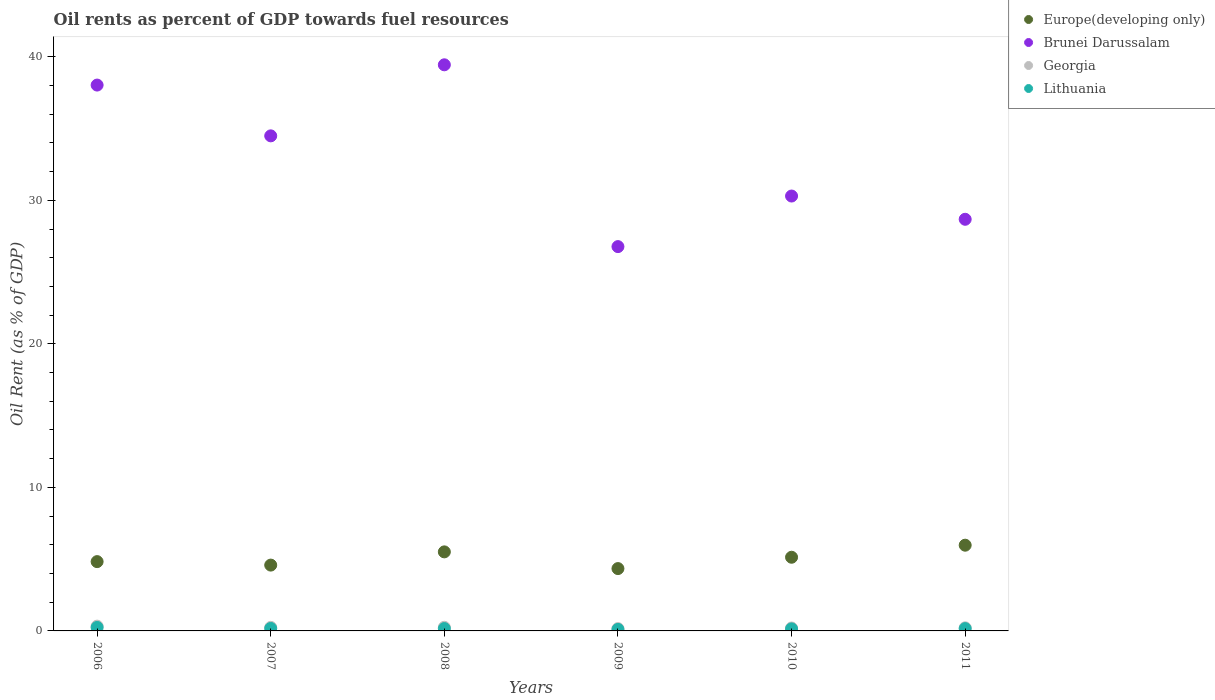How many different coloured dotlines are there?
Provide a succinct answer. 4. What is the oil rent in Lithuania in 2009?
Offer a very short reply. 0.11. Across all years, what is the maximum oil rent in Europe(developing only)?
Ensure brevity in your answer.  5.97. Across all years, what is the minimum oil rent in Brunei Darussalam?
Provide a succinct answer. 26.77. In which year was the oil rent in Brunei Darussalam minimum?
Ensure brevity in your answer.  2009. What is the total oil rent in Europe(developing only) in the graph?
Ensure brevity in your answer.  30.37. What is the difference between the oil rent in Europe(developing only) in 2008 and that in 2009?
Your response must be concise. 1.16. What is the difference between the oil rent in Lithuania in 2009 and the oil rent in Europe(developing only) in 2010?
Keep it short and to the point. -5.03. What is the average oil rent in Brunei Darussalam per year?
Make the answer very short. 32.95. In the year 2010, what is the difference between the oil rent in Georgia and oil rent in Brunei Darussalam?
Ensure brevity in your answer.  -30.09. In how many years, is the oil rent in Brunei Darussalam greater than 24 %?
Keep it short and to the point. 6. What is the ratio of the oil rent in Brunei Darussalam in 2007 to that in 2009?
Make the answer very short. 1.29. Is the oil rent in Georgia in 2009 less than that in 2011?
Ensure brevity in your answer.  Yes. Is the difference between the oil rent in Georgia in 2008 and 2011 greater than the difference between the oil rent in Brunei Darussalam in 2008 and 2011?
Keep it short and to the point. No. What is the difference between the highest and the second highest oil rent in Lithuania?
Provide a short and direct response. 0.07. What is the difference between the highest and the lowest oil rent in Brunei Darussalam?
Provide a short and direct response. 12.67. In how many years, is the oil rent in Georgia greater than the average oil rent in Georgia taken over all years?
Make the answer very short. 3. Is the sum of the oil rent in Brunei Darussalam in 2006 and 2011 greater than the maximum oil rent in Lithuania across all years?
Your answer should be very brief. Yes. Does the oil rent in Europe(developing only) monotonically increase over the years?
Your response must be concise. No. Is the oil rent in Georgia strictly greater than the oil rent in Europe(developing only) over the years?
Offer a terse response. No. Is the oil rent in Lithuania strictly less than the oil rent in Georgia over the years?
Offer a terse response. Yes. Where does the legend appear in the graph?
Make the answer very short. Top right. How are the legend labels stacked?
Offer a terse response. Vertical. What is the title of the graph?
Give a very brief answer. Oil rents as percent of GDP towards fuel resources. What is the label or title of the X-axis?
Provide a succinct answer. Years. What is the label or title of the Y-axis?
Provide a succinct answer. Oil Rent (as % of GDP). What is the Oil Rent (as % of GDP) of Europe(developing only) in 2006?
Provide a succinct answer. 4.83. What is the Oil Rent (as % of GDP) in Brunei Darussalam in 2006?
Your answer should be compact. 38.03. What is the Oil Rent (as % of GDP) of Georgia in 2006?
Give a very brief answer. 0.33. What is the Oil Rent (as % of GDP) in Lithuania in 2006?
Make the answer very short. 0.24. What is the Oil Rent (as % of GDP) of Europe(developing only) in 2007?
Provide a succinct answer. 4.59. What is the Oil Rent (as % of GDP) of Brunei Darussalam in 2007?
Give a very brief answer. 34.49. What is the Oil Rent (as % of GDP) in Georgia in 2007?
Give a very brief answer. 0.25. What is the Oil Rent (as % of GDP) in Lithuania in 2007?
Offer a very short reply. 0.17. What is the Oil Rent (as % of GDP) in Europe(developing only) in 2008?
Provide a short and direct response. 5.51. What is the Oil Rent (as % of GDP) of Brunei Darussalam in 2008?
Give a very brief answer. 39.44. What is the Oil Rent (as % of GDP) of Georgia in 2008?
Make the answer very short. 0.25. What is the Oil Rent (as % of GDP) of Lithuania in 2008?
Keep it short and to the point. 0.16. What is the Oil Rent (as % of GDP) of Europe(developing only) in 2009?
Give a very brief answer. 4.34. What is the Oil Rent (as % of GDP) in Brunei Darussalam in 2009?
Offer a terse response. 26.77. What is the Oil Rent (as % of GDP) of Georgia in 2009?
Offer a very short reply. 0.16. What is the Oil Rent (as % of GDP) of Lithuania in 2009?
Ensure brevity in your answer.  0.11. What is the Oil Rent (as % of GDP) of Europe(developing only) in 2010?
Your answer should be compact. 5.13. What is the Oil Rent (as % of GDP) of Brunei Darussalam in 2010?
Provide a succinct answer. 30.3. What is the Oil Rent (as % of GDP) of Georgia in 2010?
Keep it short and to the point. 0.2. What is the Oil Rent (as % of GDP) in Lithuania in 2010?
Your answer should be very brief. 0.14. What is the Oil Rent (as % of GDP) of Europe(developing only) in 2011?
Keep it short and to the point. 5.97. What is the Oil Rent (as % of GDP) of Brunei Darussalam in 2011?
Your response must be concise. 28.68. What is the Oil Rent (as % of GDP) of Georgia in 2011?
Provide a succinct answer. 0.22. What is the Oil Rent (as % of GDP) in Lithuania in 2011?
Provide a succinct answer. 0.16. Across all years, what is the maximum Oil Rent (as % of GDP) in Europe(developing only)?
Provide a short and direct response. 5.97. Across all years, what is the maximum Oil Rent (as % of GDP) in Brunei Darussalam?
Provide a short and direct response. 39.44. Across all years, what is the maximum Oil Rent (as % of GDP) in Georgia?
Ensure brevity in your answer.  0.33. Across all years, what is the maximum Oil Rent (as % of GDP) of Lithuania?
Your answer should be compact. 0.24. Across all years, what is the minimum Oil Rent (as % of GDP) of Europe(developing only)?
Provide a succinct answer. 4.34. Across all years, what is the minimum Oil Rent (as % of GDP) in Brunei Darussalam?
Your response must be concise. 26.77. Across all years, what is the minimum Oil Rent (as % of GDP) in Georgia?
Offer a terse response. 0.16. Across all years, what is the minimum Oil Rent (as % of GDP) in Lithuania?
Ensure brevity in your answer.  0.11. What is the total Oil Rent (as % of GDP) of Europe(developing only) in the graph?
Make the answer very short. 30.37. What is the total Oil Rent (as % of GDP) in Brunei Darussalam in the graph?
Ensure brevity in your answer.  197.71. What is the total Oil Rent (as % of GDP) of Georgia in the graph?
Offer a terse response. 1.42. What is the total Oil Rent (as % of GDP) of Lithuania in the graph?
Your answer should be very brief. 0.99. What is the difference between the Oil Rent (as % of GDP) of Europe(developing only) in 2006 and that in 2007?
Make the answer very short. 0.24. What is the difference between the Oil Rent (as % of GDP) in Brunei Darussalam in 2006 and that in 2007?
Offer a terse response. 3.54. What is the difference between the Oil Rent (as % of GDP) of Georgia in 2006 and that in 2007?
Your answer should be very brief. 0.08. What is the difference between the Oil Rent (as % of GDP) of Lithuania in 2006 and that in 2007?
Make the answer very short. 0.07. What is the difference between the Oil Rent (as % of GDP) of Europe(developing only) in 2006 and that in 2008?
Give a very brief answer. -0.68. What is the difference between the Oil Rent (as % of GDP) of Brunei Darussalam in 2006 and that in 2008?
Keep it short and to the point. -1.41. What is the difference between the Oil Rent (as % of GDP) of Georgia in 2006 and that in 2008?
Your answer should be very brief. 0.08. What is the difference between the Oil Rent (as % of GDP) of Lithuania in 2006 and that in 2008?
Your answer should be very brief. 0.08. What is the difference between the Oil Rent (as % of GDP) of Europe(developing only) in 2006 and that in 2009?
Give a very brief answer. 0.48. What is the difference between the Oil Rent (as % of GDP) of Brunei Darussalam in 2006 and that in 2009?
Your response must be concise. 11.25. What is the difference between the Oil Rent (as % of GDP) of Georgia in 2006 and that in 2009?
Your answer should be very brief. 0.17. What is the difference between the Oil Rent (as % of GDP) in Lithuania in 2006 and that in 2009?
Keep it short and to the point. 0.14. What is the difference between the Oil Rent (as % of GDP) in Europe(developing only) in 2006 and that in 2010?
Keep it short and to the point. -0.3. What is the difference between the Oil Rent (as % of GDP) in Brunei Darussalam in 2006 and that in 2010?
Offer a very short reply. 7.73. What is the difference between the Oil Rent (as % of GDP) in Georgia in 2006 and that in 2010?
Ensure brevity in your answer.  0.13. What is the difference between the Oil Rent (as % of GDP) in Lithuania in 2006 and that in 2010?
Your answer should be very brief. 0.1. What is the difference between the Oil Rent (as % of GDP) of Europe(developing only) in 2006 and that in 2011?
Offer a terse response. -1.14. What is the difference between the Oil Rent (as % of GDP) in Brunei Darussalam in 2006 and that in 2011?
Your answer should be compact. 9.35. What is the difference between the Oil Rent (as % of GDP) of Georgia in 2006 and that in 2011?
Your answer should be very brief. 0.12. What is the difference between the Oil Rent (as % of GDP) of Lithuania in 2006 and that in 2011?
Offer a terse response. 0.08. What is the difference between the Oil Rent (as % of GDP) in Europe(developing only) in 2007 and that in 2008?
Offer a very short reply. -0.92. What is the difference between the Oil Rent (as % of GDP) in Brunei Darussalam in 2007 and that in 2008?
Give a very brief answer. -4.95. What is the difference between the Oil Rent (as % of GDP) in Georgia in 2007 and that in 2008?
Keep it short and to the point. -0. What is the difference between the Oil Rent (as % of GDP) in Lithuania in 2007 and that in 2008?
Offer a very short reply. 0.01. What is the difference between the Oil Rent (as % of GDP) of Europe(developing only) in 2007 and that in 2009?
Provide a short and direct response. 0.24. What is the difference between the Oil Rent (as % of GDP) in Brunei Darussalam in 2007 and that in 2009?
Make the answer very short. 7.72. What is the difference between the Oil Rent (as % of GDP) in Georgia in 2007 and that in 2009?
Provide a short and direct response. 0.09. What is the difference between the Oil Rent (as % of GDP) of Lithuania in 2007 and that in 2009?
Make the answer very short. 0.07. What is the difference between the Oil Rent (as % of GDP) in Europe(developing only) in 2007 and that in 2010?
Offer a terse response. -0.55. What is the difference between the Oil Rent (as % of GDP) in Brunei Darussalam in 2007 and that in 2010?
Your answer should be compact. 4.19. What is the difference between the Oil Rent (as % of GDP) in Georgia in 2007 and that in 2010?
Provide a succinct answer. 0.04. What is the difference between the Oil Rent (as % of GDP) of Lithuania in 2007 and that in 2010?
Offer a terse response. 0.03. What is the difference between the Oil Rent (as % of GDP) in Europe(developing only) in 2007 and that in 2011?
Provide a short and direct response. -1.39. What is the difference between the Oil Rent (as % of GDP) in Brunei Darussalam in 2007 and that in 2011?
Provide a short and direct response. 5.81. What is the difference between the Oil Rent (as % of GDP) of Georgia in 2007 and that in 2011?
Provide a short and direct response. 0.03. What is the difference between the Oil Rent (as % of GDP) in Lithuania in 2007 and that in 2011?
Your response must be concise. 0.01. What is the difference between the Oil Rent (as % of GDP) of Europe(developing only) in 2008 and that in 2009?
Offer a terse response. 1.16. What is the difference between the Oil Rent (as % of GDP) of Brunei Darussalam in 2008 and that in 2009?
Ensure brevity in your answer.  12.67. What is the difference between the Oil Rent (as % of GDP) in Georgia in 2008 and that in 2009?
Provide a short and direct response. 0.09. What is the difference between the Oil Rent (as % of GDP) of Lithuania in 2008 and that in 2009?
Provide a short and direct response. 0.06. What is the difference between the Oil Rent (as % of GDP) in Europe(developing only) in 2008 and that in 2010?
Make the answer very short. 0.37. What is the difference between the Oil Rent (as % of GDP) in Brunei Darussalam in 2008 and that in 2010?
Provide a succinct answer. 9.14. What is the difference between the Oil Rent (as % of GDP) in Georgia in 2008 and that in 2010?
Your answer should be very brief. 0.05. What is the difference between the Oil Rent (as % of GDP) of Lithuania in 2008 and that in 2010?
Your answer should be compact. 0.02. What is the difference between the Oil Rent (as % of GDP) of Europe(developing only) in 2008 and that in 2011?
Provide a succinct answer. -0.47. What is the difference between the Oil Rent (as % of GDP) of Brunei Darussalam in 2008 and that in 2011?
Offer a very short reply. 10.76. What is the difference between the Oil Rent (as % of GDP) in Georgia in 2008 and that in 2011?
Keep it short and to the point. 0.04. What is the difference between the Oil Rent (as % of GDP) in Lithuania in 2008 and that in 2011?
Make the answer very short. 0. What is the difference between the Oil Rent (as % of GDP) in Europe(developing only) in 2009 and that in 2010?
Give a very brief answer. -0.79. What is the difference between the Oil Rent (as % of GDP) of Brunei Darussalam in 2009 and that in 2010?
Your response must be concise. -3.52. What is the difference between the Oil Rent (as % of GDP) of Georgia in 2009 and that in 2010?
Ensure brevity in your answer.  -0.04. What is the difference between the Oil Rent (as % of GDP) in Lithuania in 2009 and that in 2010?
Your response must be concise. -0.04. What is the difference between the Oil Rent (as % of GDP) in Europe(developing only) in 2009 and that in 2011?
Give a very brief answer. -1.63. What is the difference between the Oil Rent (as % of GDP) of Brunei Darussalam in 2009 and that in 2011?
Offer a very short reply. -1.9. What is the difference between the Oil Rent (as % of GDP) of Georgia in 2009 and that in 2011?
Provide a short and direct response. -0.05. What is the difference between the Oil Rent (as % of GDP) in Lithuania in 2009 and that in 2011?
Ensure brevity in your answer.  -0.06. What is the difference between the Oil Rent (as % of GDP) of Europe(developing only) in 2010 and that in 2011?
Your response must be concise. -0.84. What is the difference between the Oil Rent (as % of GDP) of Brunei Darussalam in 2010 and that in 2011?
Give a very brief answer. 1.62. What is the difference between the Oil Rent (as % of GDP) of Georgia in 2010 and that in 2011?
Make the answer very short. -0.01. What is the difference between the Oil Rent (as % of GDP) of Lithuania in 2010 and that in 2011?
Your answer should be compact. -0.02. What is the difference between the Oil Rent (as % of GDP) in Europe(developing only) in 2006 and the Oil Rent (as % of GDP) in Brunei Darussalam in 2007?
Make the answer very short. -29.66. What is the difference between the Oil Rent (as % of GDP) of Europe(developing only) in 2006 and the Oil Rent (as % of GDP) of Georgia in 2007?
Your response must be concise. 4.58. What is the difference between the Oil Rent (as % of GDP) in Europe(developing only) in 2006 and the Oil Rent (as % of GDP) in Lithuania in 2007?
Offer a terse response. 4.66. What is the difference between the Oil Rent (as % of GDP) of Brunei Darussalam in 2006 and the Oil Rent (as % of GDP) of Georgia in 2007?
Your answer should be very brief. 37.78. What is the difference between the Oil Rent (as % of GDP) in Brunei Darussalam in 2006 and the Oil Rent (as % of GDP) in Lithuania in 2007?
Ensure brevity in your answer.  37.86. What is the difference between the Oil Rent (as % of GDP) of Georgia in 2006 and the Oil Rent (as % of GDP) of Lithuania in 2007?
Your answer should be compact. 0.16. What is the difference between the Oil Rent (as % of GDP) of Europe(developing only) in 2006 and the Oil Rent (as % of GDP) of Brunei Darussalam in 2008?
Offer a terse response. -34.61. What is the difference between the Oil Rent (as % of GDP) in Europe(developing only) in 2006 and the Oil Rent (as % of GDP) in Georgia in 2008?
Ensure brevity in your answer.  4.57. What is the difference between the Oil Rent (as % of GDP) of Europe(developing only) in 2006 and the Oil Rent (as % of GDP) of Lithuania in 2008?
Your answer should be very brief. 4.66. What is the difference between the Oil Rent (as % of GDP) in Brunei Darussalam in 2006 and the Oil Rent (as % of GDP) in Georgia in 2008?
Give a very brief answer. 37.77. What is the difference between the Oil Rent (as % of GDP) in Brunei Darussalam in 2006 and the Oil Rent (as % of GDP) in Lithuania in 2008?
Provide a succinct answer. 37.86. What is the difference between the Oil Rent (as % of GDP) of Georgia in 2006 and the Oil Rent (as % of GDP) of Lithuania in 2008?
Your answer should be compact. 0.17. What is the difference between the Oil Rent (as % of GDP) in Europe(developing only) in 2006 and the Oil Rent (as % of GDP) in Brunei Darussalam in 2009?
Offer a very short reply. -21.95. What is the difference between the Oil Rent (as % of GDP) of Europe(developing only) in 2006 and the Oil Rent (as % of GDP) of Georgia in 2009?
Ensure brevity in your answer.  4.66. What is the difference between the Oil Rent (as % of GDP) in Europe(developing only) in 2006 and the Oil Rent (as % of GDP) in Lithuania in 2009?
Give a very brief answer. 4.72. What is the difference between the Oil Rent (as % of GDP) in Brunei Darussalam in 2006 and the Oil Rent (as % of GDP) in Georgia in 2009?
Your answer should be very brief. 37.87. What is the difference between the Oil Rent (as % of GDP) of Brunei Darussalam in 2006 and the Oil Rent (as % of GDP) of Lithuania in 2009?
Ensure brevity in your answer.  37.92. What is the difference between the Oil Rent (as % of GDP) in Georgia in 2006 and the Oil Rent (as % of GDP) in Lithuania in 2009?
Your answer should be very brief. 0.23. What is the difference between the Oil Rent (as % of GDP) in Europe(developing only) in 2006 and the Oil Rent (as % of GDP) in Brunei Darussalam in 2010?
Your answer should be very brief. -25.47. What is the difference between the Oil Rent (as % of GDP) in Europe(developing only) in 2006 and the Oil Rent (as % of GDP) in Georgia in 2010?
Offer a very short reply. 4.62. What is the difference between the Oil Rent (as % of GDP) in Europe(developing only) in 2006 and the Oil Rent (as % of GDP) in Lithuania in 2010?
Provide a short and direct response. 4.69. What is the difference between the Oil Rent (as % of GDP) in Brunei Darussalam in 2006 and the Oil Rent (as % of GDP) in Georgia in 2010?
Ensure brevity in your answer.  37.82. What is the difference between the Oil Rent (as % of GDP) in Brunei Darussalam in 2006 and the Oil Rent (as % of GDP) in Lithuania in 2010?
Give a very brief answer. 37.89. What is the difference between the Oil Rent (as % of GDP) in Georgia in 2006 and the Oil Rent (as % of GDP) in Lithuania in 2010?
Provide a succinct answer. 0.19. What is the difference between the Oil Rent (as % of GDP) of Europe(developing only) in 2006 and the Oil Rent (as % of GDP) of Brunei Darussalam in 2011?
Provide a short and direct response. -23.85. What is the difference between the Oil Rent (as % of GDP) of Europe(developing only) in 2006 and the Oil Rent (as % of GDP) of Georgia in 2011?
Make the answer very short. 4.61. What is the difference between the Oil Rent (as % of GDP) of Europe(developing only) in 2006 and the Oil Rent (as % of GDP) of Lithuania in 2011?
Offer a terse response. 4.67. What is the difference between the Oil Rent (as % of GDP) of Brunei Darussalam in 2006 and the Oil Rent (as % of GDP) of Georgia in 2011?
Keep it short and to the point. 37.81. What is the difference between the Oil Rent (as % of GDP) in Brunei Darussalam in 2006 and the Oil Rent (as % of GDP) in Lithuania in 2011?
Offer a terse response. 37.87. What is the difference between the Oil Rent (as % of GDP) in Georgia in 2006 and the Oil Rent (as % of GDP) in Lithuania in 2011?
Your response must be concise. 0.17. What is the difference between the Oil Rent (as % of GDP) in Europe(developing only) in 2007 and the Oil Rent (as % of GDP) in Brunei Darussalam in 2008?
Make the answer very short. -34.85. What is the difference between the Oil Rent (as % of GDP) of Europe(developing only) in 2007 and the Oil Rent (as % of GDP) of Georgia in 2008?
Offer a very short reply. 4.33. What is the difference between the Oil Rent (as % of GDP) in Europe(developing only) in 2007 and the Oil Rent (as % of GDP) in Lithuania in 2008?
Your response must be concise. 4.42. What is the difference between the Oil Rent (as % of GDP) of Brunei Darussalam in 2007 and the Oil Rent (as % of GDP) of Georgia in 2008?
Ensure brevity in your answer.  34.24. What is the difference between the Oil Rent (as % of GDP) in Brunei Darussalam in 2007 and the Oil Rent (as % of GDP) in Lithuania in 2008?
Keep it short and to the point. 34.33. What is the difference between the Oil Rent (as % of GDP) of Georgia in 2007 and the Oil Rent (as % of GDP) of Lithuania in 2008?
Your response must be concise. 0.09. What is the difference between the Oil Rent (as % of GDP) in Europe(developing only) in 2007 and the Oil Rent (as % of GDP) in Brunei Darussalam in 2009?
Ensure brevity in your answer.  -22.19. What is the difference between the Oil Rent (as % of GDP) of Europe(developing only) in 2007 and the Oil Rent (as % of GDP) of Georgia in 2009?
Ensure brevity in your answer.  4.42. What is the difference between the Oil Rent (as % of GDP) of Europe(developing only) in 2007 and the Oil Rent (as % of GDP) of Lithuania in 2009?
Offer a terse response. 4.48. What is the difference between the Oil Rent (as % of GDP) in Brunei Darussalam in 2007 and the Oil Rent (as % of GDP) in Georgia in 2009?
Your answer should be compact. 34.33. What is the difference between the Oil Rent (as % of GDP) of Brunei Darussalam in 2007 and the Oil Rent (as % of GDP) of Lithuania in 2009?
Keep it short and to the point. 34.38. What is the difference between the Oil Rent (as % of GDP) of Georgia in 2007 and the Oil Rent (as % of GDP) of Lithuania in 2009?
Your response must be concise. 0.14. What is the difference between the Oil Rent (as % of GDP) in Europe(developing only) in 2007 and the Oil Rent (as % of GDP) in Brunei Darussalam in 2010?
Ensure brevity in your answer.  -25.71. What is the difference between the Oil Rent (as % of GDP) in Europe(developing only) in 2007 and the Oil Rent (as % of GDP) in Georgia in 2010?
Offer a very short reply. 4.38. What is the difference between the Oil Rent (as % of GDP) of Europe(developing only) in 2007 and the Oil Rent (as % of GDP) of Lithuania in 2010?
Your answer should be very brief. 4.44. What is the difference between the Oil Rent (as % of GDP) in Brunei Darussalam in 2007 and the Oil Rent (as % of GDP) in Georgia in 2010?
Offer a very short reply. 34.29. What is the difference between the Oil Rent (as % of GDP) of Brunei Darussalam in 2007 and the Oil Rent (as % of GDP) of Lithuania in 2010?
Keep it short and to the point. 34.35. What is the difference between the Oil Rent (as % of GDP) in Georgia in 2007 and the Oil Rent (as % of GDP) in Lithuania in 2010?
Offer a terse response. 0.11. What is the difference between the Oil Rent (as % of GDP) in Europe(developing only) in 2007 and the Oil Rent (as % of GDP) in Brunei Darussalam in 2011?
Offer a very short reply. -24.09. What is the difference between the Oil Rent (as % of GDP) in Europe(developing only) in 2007 and the Oil Rent (as % of GDP) in Georgia in 2011?
Offer a very short reply. 4.37. What is the difference between the Oil Rent (as % of GDP) in Europe(developing only) in 2007 and the Oil Rent (as % of GDP) in Lithuania in 2011?
Provide a short and direct response. 4.42. What is the difference between the Oil Rent (as % of GDP) of Brunei Darussalam in 2007 and the Oil Rent (as % of GDP) of Georgia in 2011?
Your answer should be compact. 34.27. What is the difference between the Oil Rent (as % of GDP) of Brunei Darussalam in 2007 and the Oil Rent (as % of GDP) of Lithuania in 2011?
Make the answer very short. 34.33. What is the difference between the Oil Rent (as % of GDP) in Georgia in 2007 and the Oil Rent (as % of GDP) in Lithuania in 2011?
Provide a short and direct response. 0.09. What is the difference between the Oil Rent (as % of GDP) of Europe(developing only) in 2008 and the Oil Rent (as % of GDP) of Brunei Darussalam in 2009?
Provide a succinct answer. -21.27. What is the difference between the Oil Rent (as % of GDP) of Europe(developing only) in 2008 and the Oil Rent (as % of GDP) of Georgia in 2009?
Provide a short and direct response. 5.34. What is the difference between the Oil Rent (as % of GDP) of Europe(developing only) in 2008 and the Oil Rent (as % of GDP) of Lithuania in 2009?
Keep it short and to the point. 5.4. What is the difference between the Oil Rent (as % of GDP) of Brunei Darussalam in 2008 and the Oil Rent (as % of GDP) of Georgia in 2009?
Your answer should be very brief. 39.28. What is the difference between the Oil Rent (as % of GDP) of Brunei Darussalam in 2008 and the Oil Rent (as % of GDP) of Lithuania in 2009?
Keep it short and to the point. 39.33. What is the difference between the Oil Rent (as % of GDP) in Georgia in 2008 and the Oil Rent (as % of GDP) in Lithuania in 2009?
Your answer should be very brief. 0.15. What is the difference between the Oil Rent (as % of GDP) of Europe(developing only) in 2008 and the Oil Rent (as % of GDP) of Brunei Darussalam in 2010?
Ensure brevity in your answer.  -24.79. What is the difference between the Oil Rent (as % of GDP) in Europe(developing only) in 2008 and the Oil Rent (as % of GDP) in Georgia in 2010?
Provide a succinct answer. 5.3. What is the difference between the Oil Rent (as % of GDP) in Europe(developing only) in 2008 and the Oil Rent (as % of GDP) in Lithuania in 2010?
Provide a short and direct response. 5.37. What is the difference between the Oil Rent (as % of GDP) of Brunei Darussalam in 2008 and the Oil Rent (as % of GDP) of Georgia in 2010?
Your answer should be compact. 39.24. What is the difference between the Oil Rent (as % of GDP) of Brunei Darussalam in 2008 and the Oil Rent (as % of GDP) of Lithuania in 2010?
Provide a succinct answer. 39.3. What is the difference between the Oil Rent (as % of GDP) of Georgia in 2008 and the Oil Rent (as % of GDP) of Lithuania in 2010?
Keep it short and to the point. 0.11. What is the difference between the Oil Rent (as % of GDP) in Europe(developing only) in 2008 and the Oil Rent (as % of GDP) in Brunei Darussalam in 2011?
Provide a short and direct response. -23.17. What is the difference between the Oil Rent (as % of GDP) in Europe(developing only) in 2008 and the Oil Rent (as % of GDP) in Georgia in 2011?
Your response must be concise. 5.29. What is the difference between the Oil Rent (as % of GDP) of Europe(developing only) in 2008 and the Oil Rent (as % of GDP) of Lithuania in 2011?
Offer a very short reply. 5.35. What is the difference between the Oil Rent (as % of GDP) of Brunei Darussalam in 2008 and the Oil Rent (as % of GDP) of Georgia in 2011?
Your answer should be compact. 39.22. What is the difference between the Oil Rent (as % of GDP) of Brunei Darussalam in 2008 and the Oil Rent (as % of GDP) of Lithuania in 2011?
Provide a succinct answer. 39.28. What is the difference between the Oil Rent (as % of GDP) in Georgia in 2008 and the Oil Rent (as % of GDP) in Lithuania in 2011?
Give a very brief answer. 0.09. What is the difference between the Oil Rent (as % of GDP) in Europe(developing only) in 2009 and the Oil Rent (as % of GDP) in Brunei Darussalam in 2010?
Ensure brevity in your answer.  -25.95. What is the difference between the Oil Rent (as % of GDP) in Europe(developing only) in 2009 and the Oil Rent (as % of GDP) in Georgia in 2010?
Provide a short and direct response. 4.14. What is the difference between the Oil Rent (as % of GDP) of Europe(developing only) in 2009 and the Oil Rent (as % of GDP) of Lithuania in 2010?
Make the answer very short. 4.2. What is the difference between the Oil Rent (as % of GDP) of Brunei Darussalam in 2009 and the Oil Rent (as % of GDP) of Georgia in 2010?
Your answer should be compact. 26.57. What is the difference between the Oil Rent (as % of GDP) in Brunei Darussalam in 2009 and the Oil Rent (as % of GDP) in Lithuania in 2010?
Your answer should be very brief. 26.63. What is the difference between the Oil Rent (as % of GDP) in Georgia in 2009 and the Oil Rent (as % of GDP) in Lithuania in 2010?
Your response must be concise. 0.02. What is the difference between the Oil Rent (as % of GDP) in Europe(developing only) in 2009 and the Oil Rent (as % of GDP) in Brunei Darussalam in 2011?
Your answer should be very brief. -24.33. What is the difference between the Oil Rent (as % of GDP) in Europe(developing only) in 2009 and the Oil Rent (as % of GDP) in Georgia in 2011?
Your answer should be compact. 4.13. What is the difference between the Oil Rent (as % of GDP) of Europe(developing only) in 2009 and the Oil Rent (as % of GDP) of Lithuania in 2011?
Keep it short and to the point. 4.18. What is the difference between the Oil Rent (as % of GDP) in Brunei Darussalam in 2009 and the Oil Rent (as % of GDP) in Georgia in 2011?
Give a very brief answer. 26.56. What is the difference between the Oil Rent (as % of GDP) in Brunei Darussalam in 2009 and the Oil Rent (as % of GDP) in Lithuania in 2011?
Offer a terse response. 26.61. What is the difference between the Oil Rent (as % of GDP) of Georgia in 2009 and the Oil Rent (as % of GDP) of Lithuania in 2011?
Offer a very short reply. 0. What is the difference between the Oil Rent (as % of GDP) of Europe(developing only) in 2010 and the Oil Rent (as % of GDP) of Brunei Darussalam in 2011?
Offer a very short reply. -23.55. What is the difference between the Oil Rent (as % of GDP) of Europe(developing only) in 2010 and the Oil Rent (as % of GDP) of Georgia in 2011?
Your answer should be very brief. 4.92. What is the difference between the Oil Rent (as % of GDP) in Europe(developing only) in 2010 and the Oil Rent (as % of GDP) in Lithuania in 2011?
Your answer should be compact. 4.97. What is the difference between the Oil Rent (as % of GDP) of Brunei Darussalam in 2010 and the Oil Rent (as % of GDP) of Georgia in 2011?
Provide a short and direct response. 30.08. What is the difference between the Oil Rent (as % of GDP) of Brunei Darussalam in 2010 and the Oil Rent (as % of GDP) of Lithuania in 2011?
Your answer should be very brief. 30.14. What is the difference between the Oil Rent (as % of GDP) in Georgia in 2010 and the Oil Rent (as % of GDP) in Lithuania in 2011?
Your answer should be very brief. 0.04. What is the average Oil Rent (as % of GDP) in Europe(developing only) per year?
Keep it short and to the point. 5.06. What is the average Oil Rent (as % of GDP) of Brunei Darussalam per year?
Keep it short and to the point. 32.95. What is the average Oil Rent (as % of GDP) of Georgia per year?
Provide a succinct answer. 0.24. What is the average Oil Rent (as % of GDP) in Lithuania per year?
Give a very brief answer. 0.16. In the year 2006, what is the difference between the Oil Rent (as % of GDP) in Europe(developing only) and Oil Rent (as % of GDP) in Brunei Darussalam?
Your answer should be compact. -33.2. In the year 2006, what is the difference between the Oil Rent (as % of GDP) in Europe(developing only) and Oil Rent (as % of GDP) in Georgia?
Ensure brevity in your answer.  4.49. In the year 2006, what is the difference between the Oil Rent (as % of GDP) of Europe(developing only) and Oil Rent (as % of GDP) of Lithuania?
Keep it short and to the point. 4.59. In the year 2006, what is the difference between the Oil Rent (as % of GDP) of Brunei Darussalam and Oil Rent (as % of GDP) of Georgia?
Provide a short and direct response. 37.69. In the year 2006, what is the difference between the Oil Rent (as % of GDP) in Brunei Darussalam and Oil Rent (as % of GDP) in Lithuania?
Provide a short and direct response. 37.79. In the year 2006, what is the difference between the Oil Rent (as % of GDP) in Georgia and Oil Rent (as % of GDP) in Lithuania?
Provide a succinct answer. 0.09. In the year 2007, what is the difference between the Oil Rent (as % of GDP) in Europe(developing only) and Oil Rent (as % of GDP) in Brunei Darussalam?
Your response must be concise. -29.9. In the year 2007, what is the difference between the Oil Rent (as % of GDP) of Europe(developing only) and Oil Rent (as % of GDP) of Georgia?
Offer a very short reply. 4.34. In the year 2007, what is the difference between the Oil Rent (as % of GDP) in Europe(developing only) and Oil Rent (as % of GDP) in Lithuania?
Your answer should be compact. 4.41. In the year 2007, what is the difference between the Oil Rent (as % of GDP) of Brunei Darussalam and Oil Rent (as % of GDP) of Georgia?
Your answer should be very brief. 34.24. In the year 2007, what is the difference between the Oil Rent (as % of GDP) of Brunei Darussalam and Oil Rent (as % of GDP) of Lithuania?
Offer a terse response. 34.32. In the year 2007, what is the difference between the Oil Rent (as % of GDP) of Georgia and Oil Rent (as % of GDP) of Lithuania?
Keep it short and to the point. 0.08. In the year 2008, what is the difference between the Oil Rent (as % of GDP) of Europe(developing only) and Oil Rent (as % of GDP) of Brunei Darussalam?
Your answer should be compact. -33.93. In the year 2008, what is the difference between the Oil Rent (as % of GDP) of Europe(developing only) and Oil Rent (as % of GDP) of Georgia?
Your response must be concise. 5.25. In the year 2008, what is the difference between the Oil Rent (as % of GDP) of Europe(developing only) and Oil Rent (as % of GDP) of Lithuania?
Your response must be concise. 5.34. In the year 2008, what is the difference between the Oil Rent (as % of GDP) of Brunei Darussalam and Oil Rent (as % of GDP) of Georgia?
Provide a succinct answer. 39.19. In the year 2008, what is the difference between the Oil Rent (as % of GDP) of Brunei Darussalam and Oil Rent (as % of GDP) of Lithuania?
Provide a succinct answer. 39.28. In the year 2008, what is the difference between the Oil Rent (as % of GDP) in Georgia and Oil Rent (as % of GDP) in Lithuania?
Provide a succinct answer. 0.09. In the year 2009, what is the difference between the Oil Rent (as % of GDP) in Europe(developing only) and Oil Rent (as % of GDP) in Brunei Darussalam?
Your response must be concise. -22.43. In the year 2009, what is the difference between the Oil Rent (as % of GDP) of Europe(developing only) and Oil Rent (as % of GDP) of Georgia?
Your answer should be compact. 4.18. In the year 2009, what is the difference between the Oil Rent (as % of GDP) in Europe(developing only) and Oil Rent (as % of GDP) in Lithuania?
Provide a short and direct response. 4.24. In the year 2009, what is the difference between the Oil Rent (as % of GDP) in Brunei Darussalam and Oil Rent (as % of GDP) in Georgia?
Provide a succinct answer. 26.61. In the year 2009, what is the difference between the Oil Rent (as % of GDP) of Brunei Darussalam and Oil Rent (as % of GDP) of Lithuania?
Provide a short and direct response. 26.67. In the year 2009, what is the difference between the Oil Rent (as % of GDP) of Georgia and Oil Rent (as % of GDP) of Lithuania?
Provide a succinct answer. 0.06. In the year 2010, what is the difference between the Oil Rent (as % of GDP) of Europe(developing only) and Oil Rent (as % of GDP) of Brunei Darussalam?
Give a very brief answer. -25.17. In the year 2010, what is the difference between the Oil Rent (as % of GDP) of Europe(developing only) and Oil Rent (as % of GDP) of Georgia?
Provide a succinct answer. 4.93. In the year 2010, what is the difference between the Oil Rent (as % of GDP) in Europe(developing only) and Oil Rent (as % of GDP) in Lithuania?
Ensure brevity in your answer.  4.99. In the year 2010, what is the difference between the Oil Rent (as % of GDP) in Brunei Darussalam and Oil Rent (as % of GDP) in Georgia?
Your response must be concise. 30.09. In the year 2010, what is the difference between the Oil Rent (as % of GDP) of Brunei Darussalam and Oil Rent (as % of GDP) of Lithuania?
Make the answer very short. 30.16. In the year 2010, what is the difference between the Oil Rent (as % of GDP) in Georgia and Oil Rent (as % of GDP) in Lithuania?
Make the answer very short. 0.06. In the year 2011, what is the difference between the Oil Rent (as % of GDP) in Europe(developing only) and Oil Rent (as % of GDP) in Brunei Darussalam?
Make the answer very short. -22.71. In the year 2011, what is the difference between the Oil Rent (as % of GDP) in Europe(developing only) and Oil Rent (as % of GDP) in Georgia?
Your answer should be compact. 5.76. In the year 2011, what is the difference between the Oil Rent (as % of GDP) in Europe(developing only) and Oil Rent (as % of GDP) in Lithuania?
Offer a very short reply. 5.81. In the year 2011, what is the difference between the Oil Rent (as % of GDP) in Brunei Darussalam and Oil Rent (as % of GDP) in Georgia?
Keep it short and to the point. 28.46. In the year 2011, what is the difference between the Oil Rent (as % of GDP) in Brunei Darussalam and Oil Rent (as % of GDP) in Lithuania?
Ensure brevity in your answer.  28.52. In the year 2011, what is the difference between the Oil Rent (as % of GDP) of Georgia and Oil Rent (as % of GDP) of Lithuania?
Give a very brief answer. 0.06. What is the ratio of the Oil Rent (as % of GDP) of Europe(developing only) in 2006 to that in 2007?
Keep it short and to the point. 1.05. What is the ratio of the Oil Rent (as % of GDP) in Brunei Darussalam in 2006 to that in 2007?
Provide a succinct answer. 1.1. What is the ratio of the Oil Rent (as % of GDP) in Georgia in 2006 to that in 2007?
Provide a succinct answer. 1.34. What is the ratio of the Oil Rent (as % of GDP) of Lithuania in 2006 to that in 2007?
Make the answer very short. 1.41. What is the ratio of the Oil Rent (as % of GDP) of Europe(developing only) in 2006 to that in 2008?
Offer a terse response. 0.88. What is the ratio of the Oil Rent (as % of GDP) in Brunei Darussalam in 2006 to that in 2008?
Your answer should be compact. 0.96. What is the ratio of the Oil Rent (as % of GDP) in Georgia in 2006 to that in 2008?
Offer a very short reply. 1.32. What is the ratio of the Oil Rent (as % of GDP) in Lithuania in 2006 to that in 2008?
Your response must be concise. 1.48. What is the ratio of the Oil Rent (as % of GDP) of Europe(developing only) in 2006 to that in 2009?
Offer a very short reply. 1.11. What is the ratio of the Oil Rent (as % of GDP) of Brunei Darussalam in 2006 to that in 2009?
Make the answer very short. 1.42. What is the ratio of the Oil Rent (as % of GDP) in Georgia in 2006 to that in 2009?
Provide a succinct answer. 2.04. What is the ratio of the Oil Rent (as % of GDP) of Lithuania in 2006 to that in 2009?
Offer a very short reply. 2.28. What is the ratio of the Oil Rent (as % of GDP) in Europe(developing only) in 2006 to that in 2010?
Provide a succinct answer. 0.94. What is the ratio of the Oil Rent (as % of GDP) in Brunei Darussalam in 2006 to that in 2010?
Your answer should be very brief. 1.26. What is the ratio of the Oil Rent (as % of GDP) in Georgia in 2006 to that in 2010?
Offer a terse response. 1.63. What is the ratio of the Oil Rent (as % of GDP) of Lithuania in 2006 to that in 2010?
Offer a very short reply. 1.71. What is the ratio of the Oil Rent (as % of GDP) in Europe(developing only) in 2006 to that in 2011?
Your answer should be compact. 0.81. What is the ratio of the Oil Rent (as % of GDP) in Brunei Darussalam in 2006 to that in 2011?
Ensure brevity in your answer.  1.33. What is the ratio of the Oil Rent (as % of GDP) of Georgia in 2006 to that in 2011?
Ensure brevity in your answer.  1.54. What is the ratio of the Oil Rent (as % of GDP) of Lithuania in 2006 to that in 2011?
Your answer should be very brief. 1.5. What is the ratio of the Oil Rent (as % of GDP) of Europe(developing only) in 2007 to that in 2008?
Make the answer very short. 0.83. What is the ratio of the Oil Rent (as % of GDP) in Brunei Darussalam in 2007 to that in 2008?
Your response must be concise. 0.87. What is the ratio of the Oil Rent (as % of GDP) in Georgia in 2007 to that in 2008?
Provide a short and direct response. 0.98. What is the ratio of the Oil Rent (as % of GDP) in Lithuania in 2007 to that in 2008?
Keep it short and to the point. 1.05. What is the ratio of the Oil Rent (as % of GDP) of Europe(developing only) in 2007 to that in 2009?
Your answer should be compact. 1.06. What is the ratio of the Oil Rent (as % of GDP) in Brunei Darussalam in 2007 to that in 2009?
Provide a succinct answer. 1.29. What is the ratio of the Oil Rent (as % of GDP) in Georgia in 2007 to that in 2009?
Your answer should be very brief. 1.52. What is the ratio of the Oil Rent (as % of GDP) in Lithuania in 2007 to that in 2009?
Your answer should be very brief. 1.63. What is the ratio of the Oil Rent (as % of GDP) in Europe(developing only) in 2007 to that in 2010?
Your answer should be compact. 0.89. What is the ratio of the Oil Rent (as % of GDP) of Brunei Darussalam in 2007 to that in 2010?
Ensure brevity in your answer.  1.14. What is the ratio of the Oil Rent (as % of GDP) of Georgia in 2007 to that in 2010?
Offer a terse response. 1.22. What is the ratio of the Oil Rent (as % of GDP) in Lithuania in 2007 to that in 2010?
Provide a succinct answer. 1.21. What is the ratio of the Oil Rent (as % of GDP) in Europe(developing only) in 2007 to that in 2011?
Ensure brevity in your answer.  0.77. What is the ratio of the Oil Rent (as % of GDP) of Brunei Darussalam in 2007 to that in 2011?
Keep it short and to the point. 1.2. What is the ratio of the Oil Rent (as % of GDP) of Georgia in 2007 to that in 2011?
Provide a short and direct response. 1.15. What is the ratio of the Oil Rent (as % of GDP) in Lithuania in 2007 to that in 2011?
Your answer should be compact. 1.07. What is the ratio of the Oil Rent (as % of GDP) in Europe(developing only) in 2008 to that in 2009?
Offer a very short reply. 1.27. What is the ratio of the Oil Rent (as % of GDP) in Brunei Darussalam in 2008 to that in 2009?
Ensure brevity in your answer.  1.47. What is the ratio of the Oil Rent (as % of GDP) of Georgia in 2008 to that in 2009?
Ensure brevity in your answer.  1.55. What is the ratio of the Oil Rent (as % of GDP) of Lithuania in 2008 to that in 2009?
Provide a succinct answer. 1.55. What is the ratio of the Oil Rent (as % of GDP) of Europe(developing only) in 2008 to that in 2010?
Make the answer very short. 1.07. What is the ratio of the Oil Rent (as % of GDP) of Brunei Darussalam in 2008 to that in 2010?
Ensure brevity in your answer.  1.3. What is the ratio of the Oil Rent (as % of GDP) in Georgia in 2008 to that in 2010?
Your answer should be compact. 1.24. What is the ratio of the Oil Rent (as % of GDP) in Lithuania in 2008 to that in 2010?
Your answer should be very brief. 1.15. What is the ratio of the Oil Rent (as % of GDP) in Europe(developing only) in 2008 to that in 2011?
Provide a short and direct response. 0.92. What is the ratio of the Oil Rent (as % of GDP) in Brunei Darussalam in 2008 to that in 2011?
Give a very brief answer. 1.38. What is the ratio of the Oil Rent (as % of GDP) of Georgia in 2008 to that in 2011?
Offer a terse response. 1.17. What is the ratio of the Oil Rent (as % of GDP) in Lithuania in 2008 to that in 2011?
Give a very brief answer. 1.02. What is the ratio of the Oil Rent (as % of GDP) in Europe(developing only) in 2009 to that in 2010?
Offer a very short reply. 0.85. What is the ratio of the Oil Rent (as % of GDP) in Brunei Darussalam in 2009 to that in 2010?
Provide a short and direct response. 0.88. What is the ratio of the Oil Rent (as % of GDP) of Georgia in 2009 to that in 2010?
Keep it short and to the point. 0.8. What is the ratio of the Oil Rent (as % of GDP) in Lithuania in 2009 to that in 2010?
Offer a very short reply. 0.75. What is the ratio of the Oil Rent (as % of GDP) in Europe(developing only) in 2009 to that in 2011?
Ensure brevity in your answer.  0.73. What is the ratio of the Oil Rent (as % of GDP) in Brunei Darussalam in 2009 to that in 2011?
Your answer should be compact. 0.93. What is the ratio of the Oil Rent (as % of GDP) of Georgia in 2009 to that in 2011?
Keep it short and to the point. 0.75. What is the ratio of the Oil Rent (as % of GDP) of Lithuania in 2009 to that in 2011?
Give a very brief answer. 0.66. What is the ratio of the Oil Rent (as % of GDP) in Europe(developing only) in 2010 to that in 2011?
Make the answer very short. 0.86. What is the ratio of the Oil Rent (as % of GDP) of Brunei Darussalam in 2010 to that in 2011?
Ensure brevity in your answer.  1.06. What is the ratio of the Oil Rent (as % of GDP) in Georgia in 2010 to that in 2011?
Give a very brief answer. 0.94. What is the ratio of the Oil Rent (as % of GDP) in Lithuania in 2010 to that in 2011?
Your response must be concise. 0.88. What is the difference between the highest and the second highest Oil Rent (as % of GDP) of Europe(developing only)?
Your answer should be very brief. 0.47. What is the difference between the highest and the second highest Oil Rent (as % of GDP) of Brunei Darussalam?
Provide a succinct answer. 1.41. What is the difference between the highest and the second highest Oil Rent (as % of GDP) of Georgia?
Ensure brevity in your answer.  0.08. What is the difference between the highest and the second highest Oil Rent (as % of GDP) of Lithuania?
Your answer should be very brief. 0.07. What is the difference between the highest and the lowest Oil Rent (as % of GDP) in Europe(developing only)?
Your response must be concise. 1.63. What is the difference between the highest and the lowest Oil Rent (as % of GDP) of Brunei Darussalam?
Offer a very short reply. 12.67. What is the difference between the highest and the lowest Oil Rent (as % of GDP) of Georgia?
Give a very brief answer. 0.17. What is the difference between the highest and the lowest Oil Rent (as % of GDP) of Lithuania?
Give a very brief answer. 0.14. 